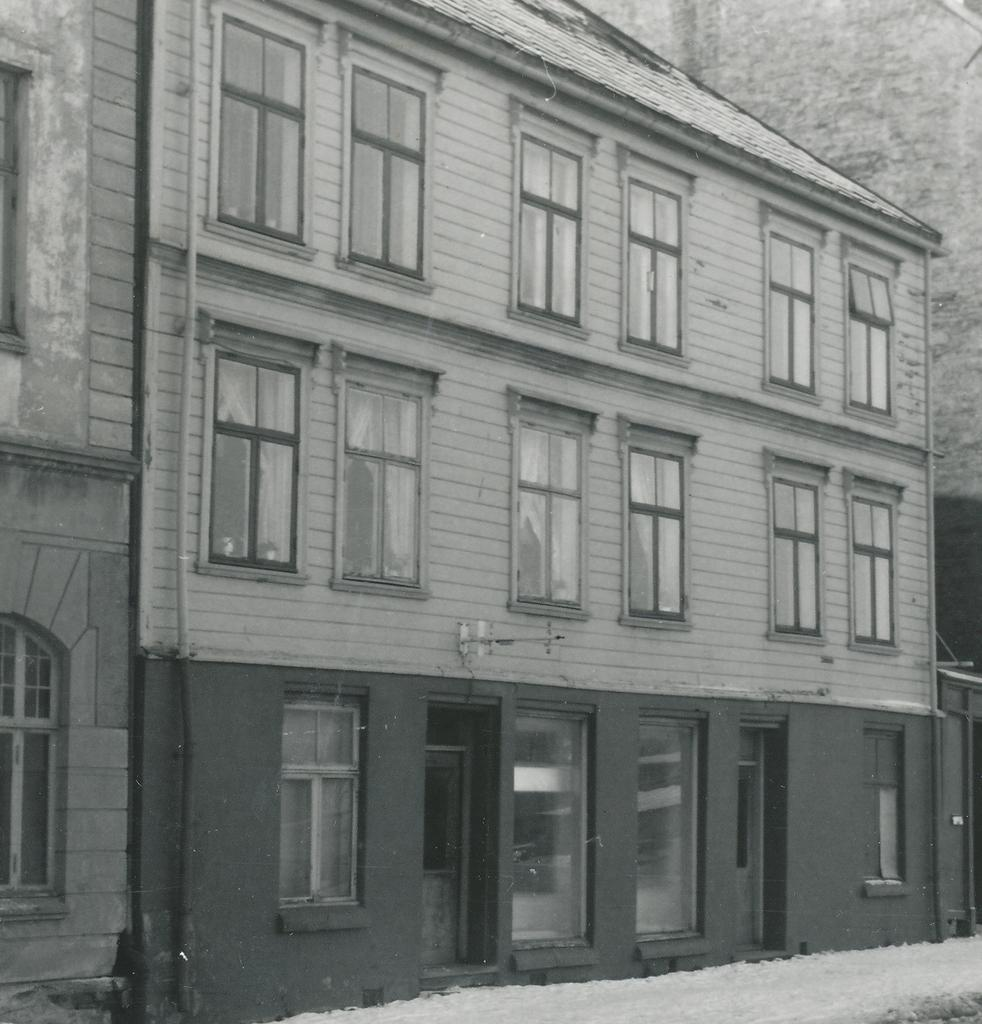What is the color scheme of the image? The image is black and white. What type of structure is present in the image? There is a building in the image. What are some features of the building? The building has many windows and doors. What is the weather like in the image? There is white snow visible in the image, indicating a snowy or cold environment. How many eyes can be seen on the building in the image? There are no eyes present on the building in the image; it is a structure and not a living being. 